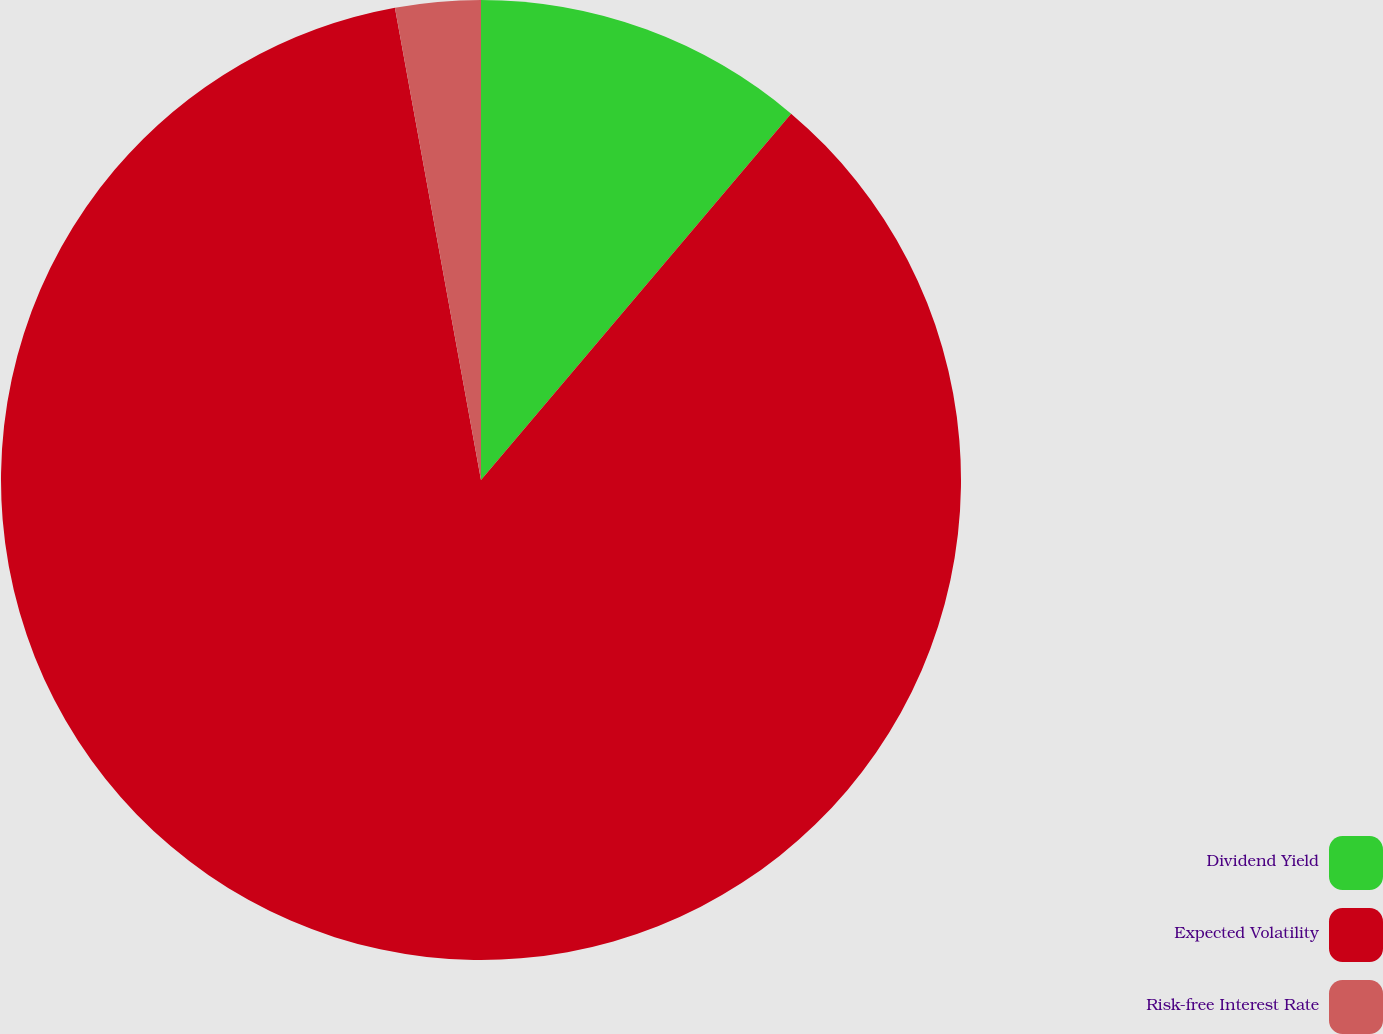Convert chart. <chart><loc_0><loc_0><loc_500><loc_500><pie_chart><fcel>Dividend Yield<fcel>Expected Volatility<fcel>Risk-free Interest Rate<nl><fcel>11.18%<fcel>85.95%<fcel>2.87%<nl></chart> 